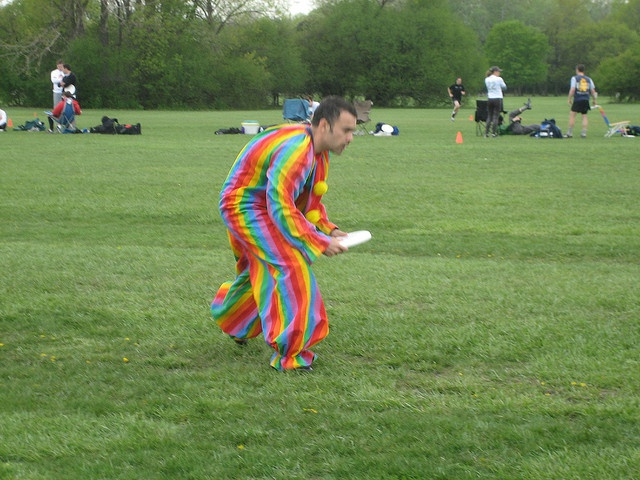Describe the objects in this image and their specific colors. I can see people in beige, red, brown, orange, and lightblue tones, people in beige, darkgray, gray, black, and tan tones, people in beige, gray, lavender, black, and lightblue tones, people in beige, gray, blue, black, and brown tones, and chair in beige, gray, blue, and teal tones in this image. 